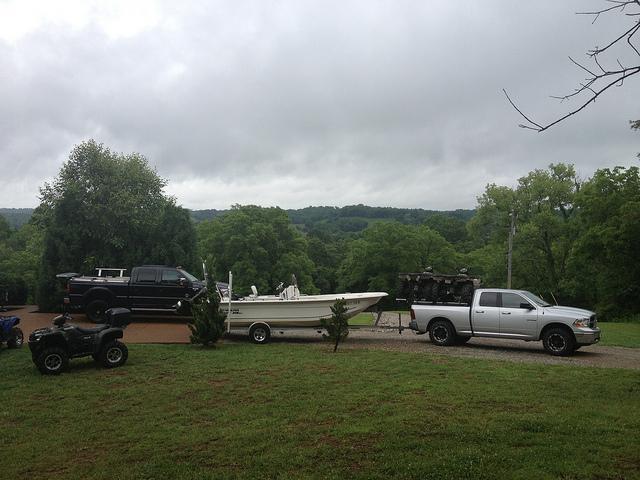How many trucks are in the photo?
Give a very brief answer. 2. 